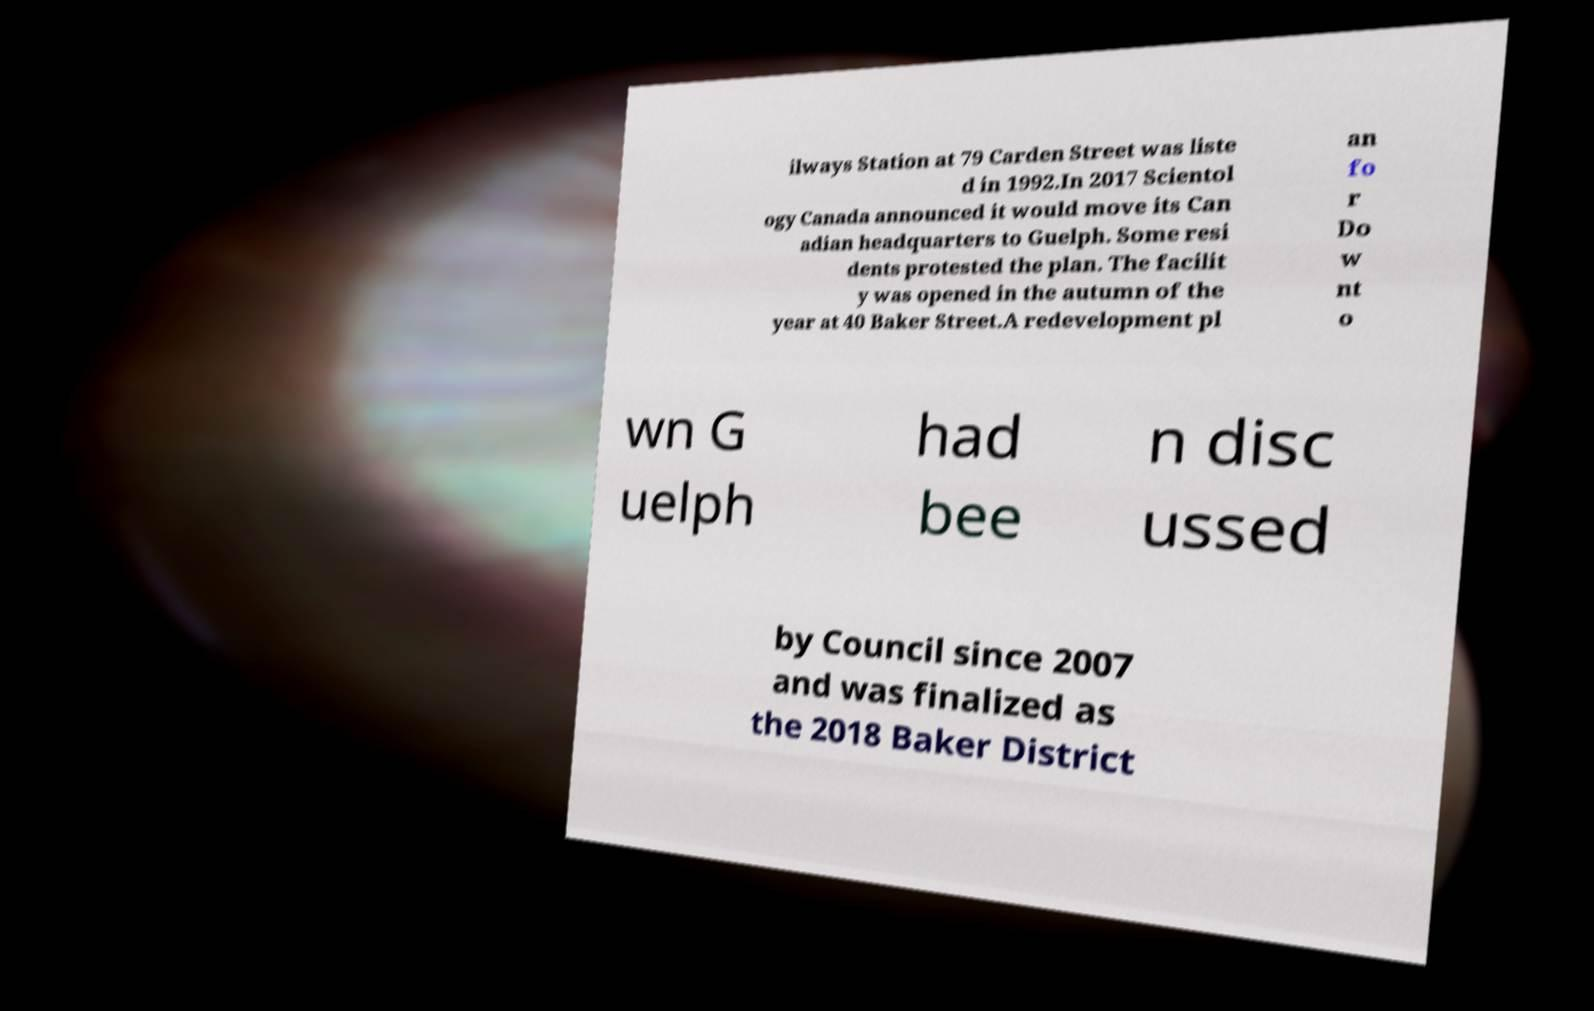Could you assist in decoding the text presented in this image and type it out clearly? ilways Station at 79 Carden Street was liste d in 1992.In 2017 Scientol ogy Canada announced it would move its Can adian headquarters to Guelph. Some resi dents protested the plan. The facilit y was opened in the autumn of the year at 40 Baker Street.A redevelopment pl an fo r Do w nt o wn G uelph had bee n disc ussed by Council since 2007 and was finalized as the 2018 Baker District 